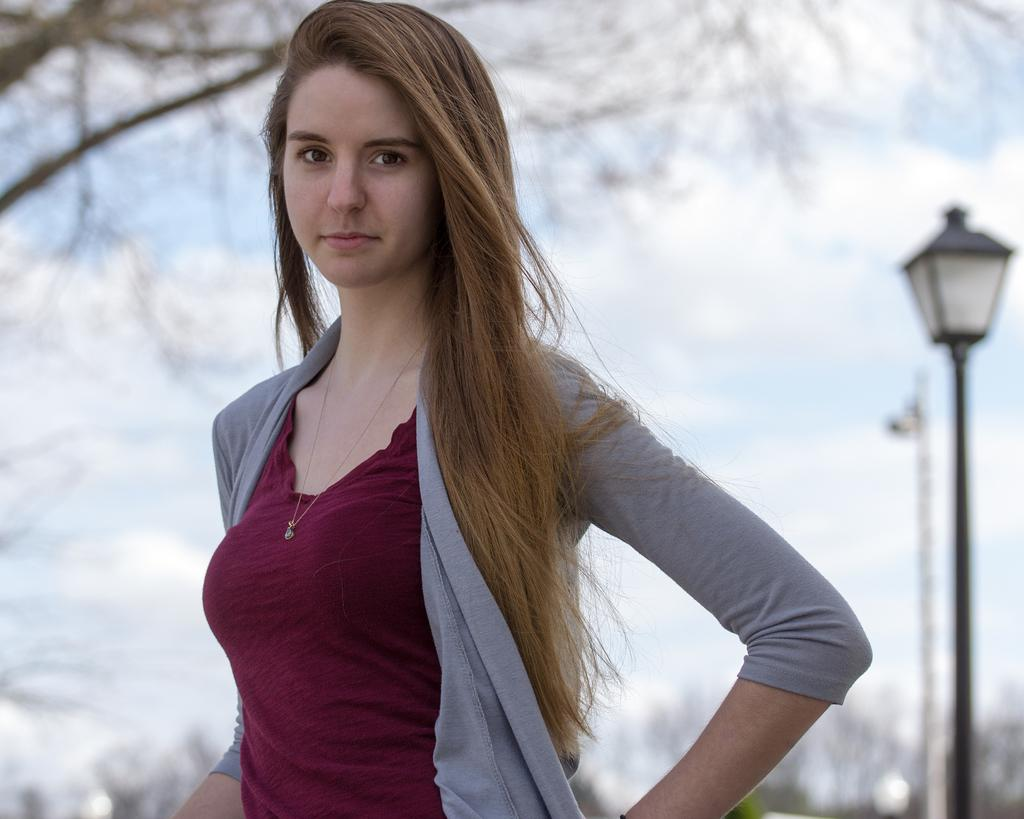Who is the main subject in the image? There is a girl in the center of the image. What is the girl wearing? The girl is wearing a shrug. What can be seen in the background of the image? There is snow, a light pole, and a tree in the background of the image. How many screws are visible on the faucet in the image? There is no faucet present in the image, so it is not possible to determine the number of screws. 